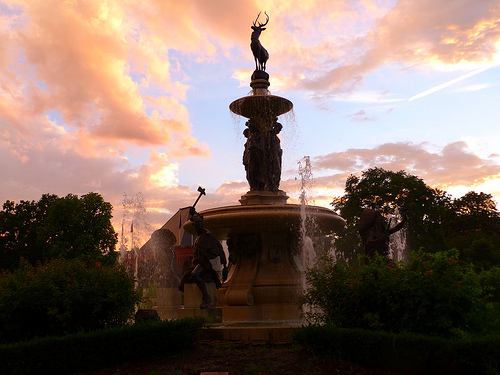<image>
Is there a statue above the hedge? Yes. The statue is positioned above the hedge in the vertical space, higher up in the scene. 